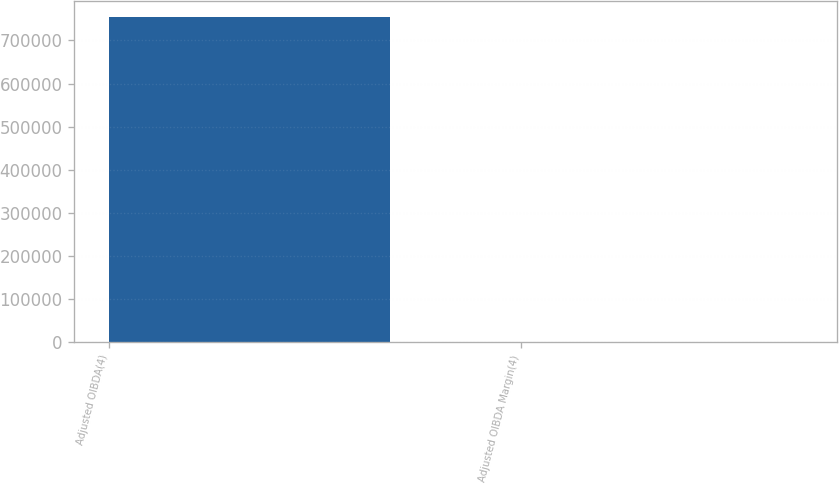<chart> <loc_0><loc_0><loc_500><loc_500><bar_chart><fcel>Adjusted OIBDA(4)<fcel>Adjusted OIBDA Margin(4)<nl><fcel>754279<fcel>26.7<nl></chart> 